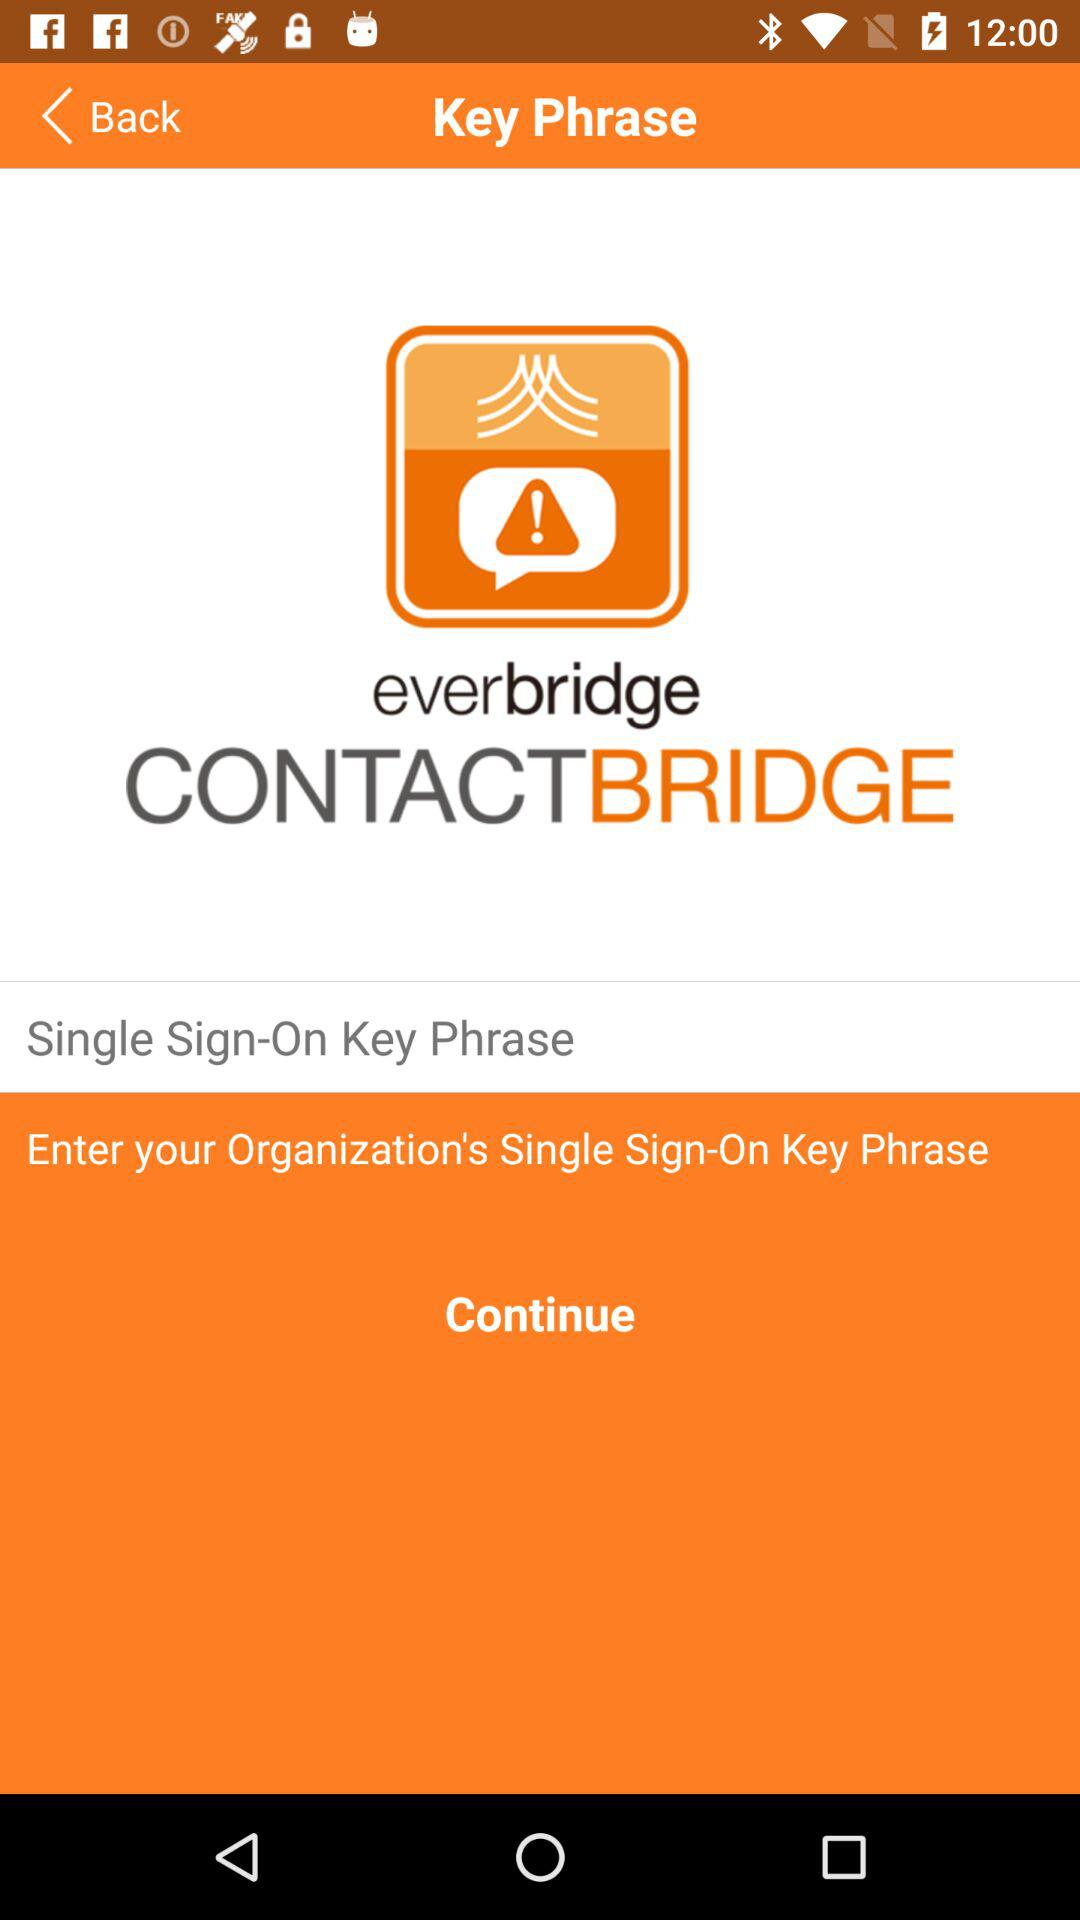What is the name of the application? The name of the application is "everbridge". 